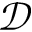<formula> <loc_0><loc_0><loc_500><loc_500>\mathcal { D }</formula> 